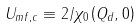<formula> <loc_0><loc_0><loc_500><loc_500>U _ { m f , c } \equiv 2 / \chi _ { 0 } \left ( { Q } _ { d } , 0 \right )</formula> 